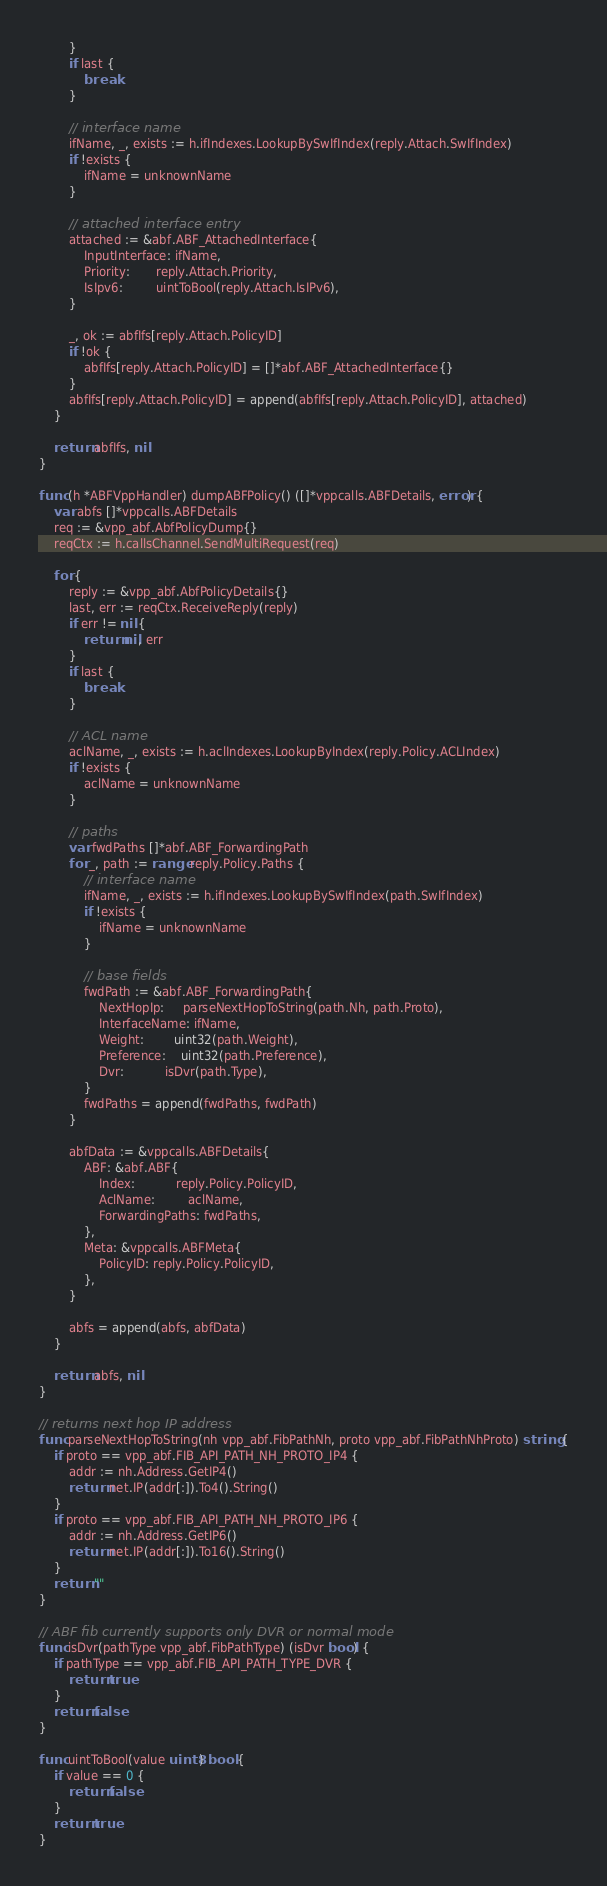<code> <loc_0><loc_0><loc_500><loc_500><_Go_>		}
		if last {
			break
		}

		// interface name
		ifName, _, exists := h.ifIndexes.LookupBySwIfIndex(reply.Attach.SwIfIndex)
		if !exists {
			ifName = unknownName
		}

		// attached interface entry
		attached := &abf.ABF_AttachedInterface{
			InputInterface: ifName,
			Priority:       reply.Attach.Priority,
			IsIpv6:         uintToBool(reply.Attach.IsIPv6),
		}

		_, ok := abfIfs[reply.Attach.PolicyID]
		if !ok {
			abfIfs[reply.Attach.PolicyID] = []*abf.ABF_AttachedInterface{}
		}
		abfIfs[reply.Attach.PolicyID] = append(abfIfs[reply.Attach.PolicyID], attached)
	}

	return abfIfs, nil
}

func (h *ABFVppHandler) dumpABFPolicy() ([]*vppcalls.ABFDetails, error) {
	var abfs []*vppcalls.ABFDetails
	req := &vpp_abf.AbfPolicyDump{}
	reqCtx := h.callsChannel.SendMultiRequest(req)

	for {
		reply := &vpp_abf.AbfPolicyDetails{}
		last, err := reqCtx.ReceiveReply(reply)
		if err != nil {
			return nil, err
		}
		if last {
			break
		}

		// ACL name
		aclName, _, exists := h.aclIndexes.LookupByIndex(reply.Policy.ACLIndex)
		if !exists {
			aclName = unknownName
		}

		// paths
		var fwdPaths []*abf.ABF_ForwardingPath
		for _, path := range reply.Policy.Paths {
			// interface name
			ifName, _, exists := h.ifIndexes.LookupBySwIfIndex(path.SwIfIndex)
			if !exists {
				ifName = unknownName
			}

			// base fields
			fwdPath := &abf.ABF_ForwardingPath{
				NextHopIp:     parseNextHopToString(path.Nh, path.Proto),
				InterfaceName: ifName,
				Weight:        uint32(path.Weight),
				Preference:    uint32(path.Preference),
				Dvr:           isDvr(path.Type),
			}
			fwdPaths = append(fwdPaths, fwdPath)
		}

		abfData := &vppcalls.ABFDetails{
			ABF: &abf.ABF{
				Index:           reply.Policy.PolicyID,
				AclName:         aclName,
				ForwardingPaths: fwdPaths,
			},
			Meta: &vppcalls.ABFMeta{
				PolicyID: reply.Policy.PolicyID,
			},
		}

		abfs = append(abfs, abfData)
	}

	return abfs, nil
}

// returns next hop IP address
func parseNextHopToString(nh vpp_abf.FibPathNh, proto vpp_abf.FibPathNhProto) string {
	if proto == vpp_abf.FIB_API_PATH_NH_PROTO_IP4 {
		addr := nh.Address.GetIP4()
		return net.IP(addr[:]).To4().String()
	}
	if proto == vpp_abf.FIB_API_PATH_NH_PROTO_IP6 {
		addr := nh.Address.GetIP6()
		return net.IP(addr[:]).To16().String()
	}
	return ""
}

// ABF fib currently supports only DVR or normal mode
func isDvr(pathType vpp_abf.FibPathType) (isDvr bool) {
	if pathType == vpp_abf.FIB_API_PATH_TYPE_DVR {
		return true
	}
	return false
}

func uintToBool(value uint8) bool {
	if value == 0 {
		return false
	}
	return true
}
</code> 